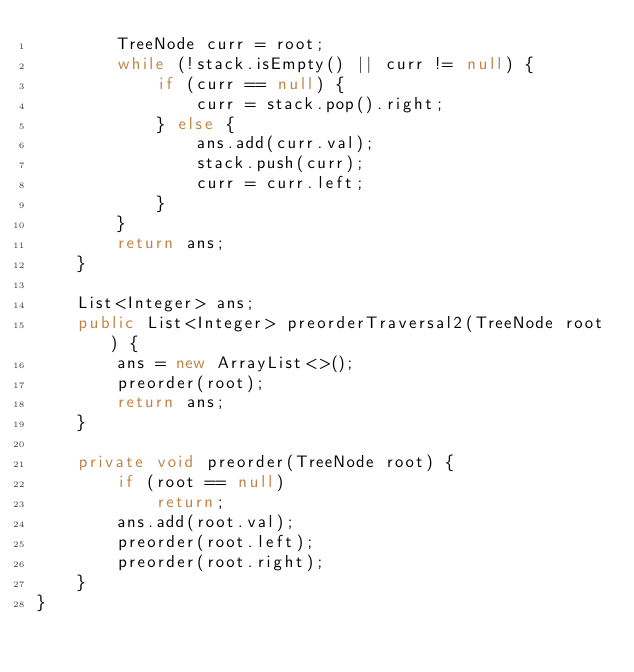Convert code to text. <code><loc_0><loc_0><loc_500><loc_500><_Java_>        TreeNode curr = root;
        while (!stack.isEmpty() || curr != null) {
            if (curr == null) {
                curr = stack.pop().right;
            } else {
                ans.add(curr.val);
                stack.push(curr);
                curr = curr.left;
            }
        }
        return ans;
    }

    List<Integer> ans;
    public List<Integer> preorderTraversal2(TreeNode root) {
        ans = new ArrayList<>();
        preorder(root);
        return ans;
    }

    private void preorder(TreeNode root) {
        if (root == null)
            return;
        ans.add(root.val);
        preorder(root.left);
        preorder(root.right);
    }
}
</code> 